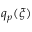Convert formula to latex. <formula><loc_0><loc_0><loc_500><loc_500>q _ { p } ( \xi )</formula> 